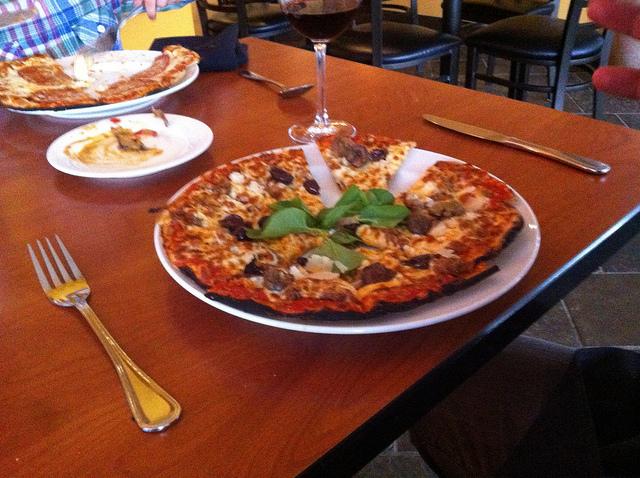What country does this food originate from?
Short answer required. Italy. Is this meal easy to prepare?
Quick response, please. Yes. How many people are dining?
Keep it brief. 2. How many slices does this pizza have?
Be succinct. 8. 